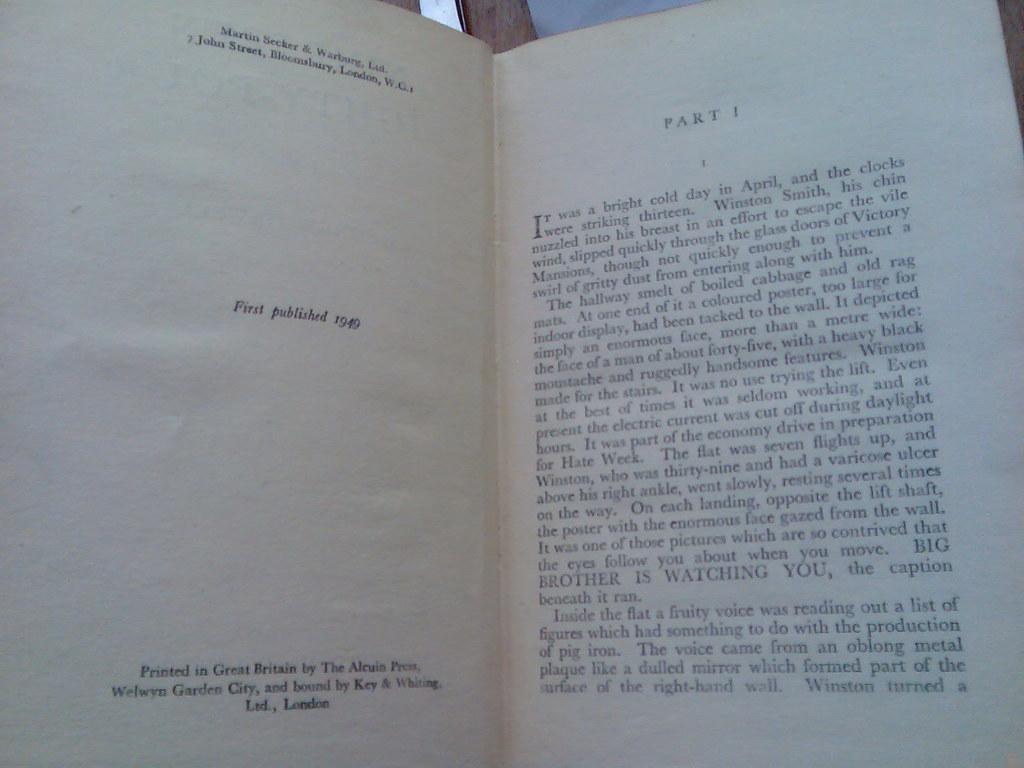When was the book first published?
Your answer should be very brief. 1949. What part is it?
Your answer should be very brief. 1. 